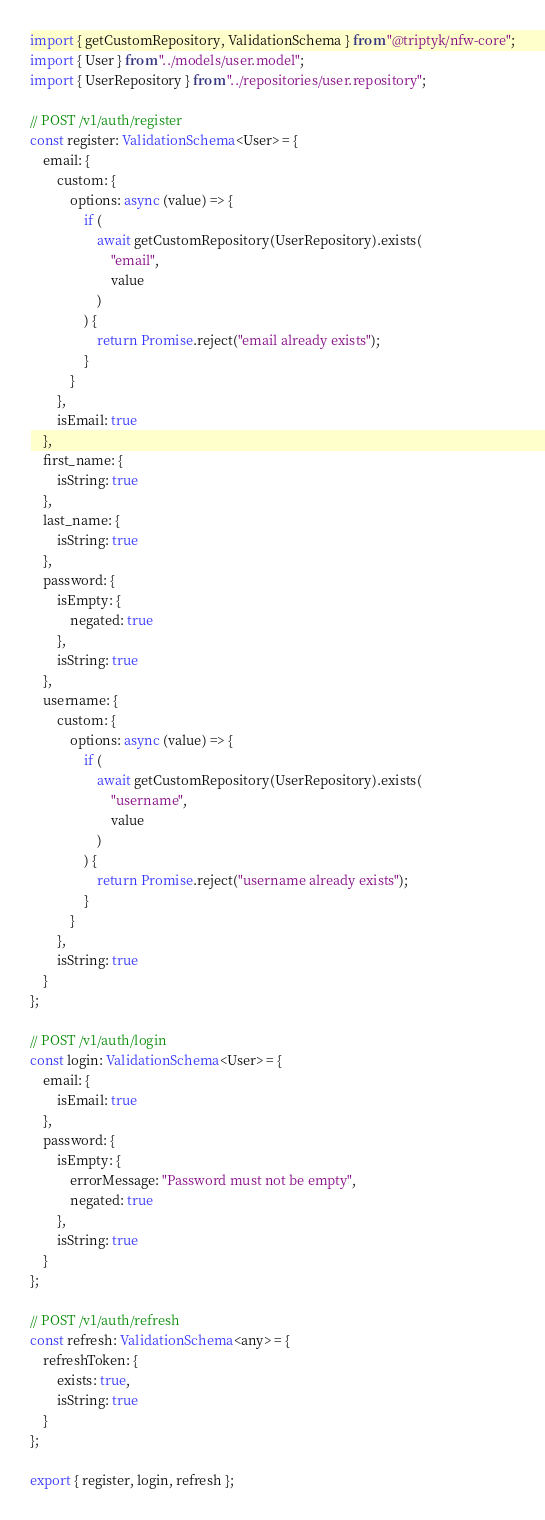Convert code to text. <code><loc_0><loc_0><loc_500><loc_500><_TypeScript_>import { getCustomRepository, ValidationSchema } from "@triptyk/nfw-core";
import { User } from "../models/user.model";
import { UserRepository } from "../repositories/user.repository";

// POST /v1/auth/register
const register: ValidationSchema<User> = {
    email: {
        custom: {
            options: async (value) => {
                if (
                    await getCustomRepository(UserRepository).exists(
                        "email",
                        value
                    )
                ) {
                    return Promise.reject("email already exists");
                }
            }
        },
        isEmail: true
    },
    first_name: {
        isString: true
    },
    last_name: {
        isString: true
    },
    password: {
        isEmpty: {
            negated: true
        },
        isString: true
    },
    username: {
        custom: {
            options: async (value) => {
                if (
                    await getCustomRepository(UserRepository).exists(
                        "username",
                        value
                    )
                ) {
                    return Promise.reject("username already exists");
                }
            }
        },
        isString: true
    }
};

// POST /v1/auth/login
const login: ValidationSchema<User> = {
    email: {
        isEmail: true
    },
    password: {
        isEmpty: {
            errorMessage: "Password must not be empty",
            negated: true
        },
        isString: true
    }
};

// POST /v1/auth/refresh
const refresh: ValidationSchema<any> = {
    refreshToken: {
        exists: true,
        isString: true
    }
};

export { register, login, refresh };
</code> 